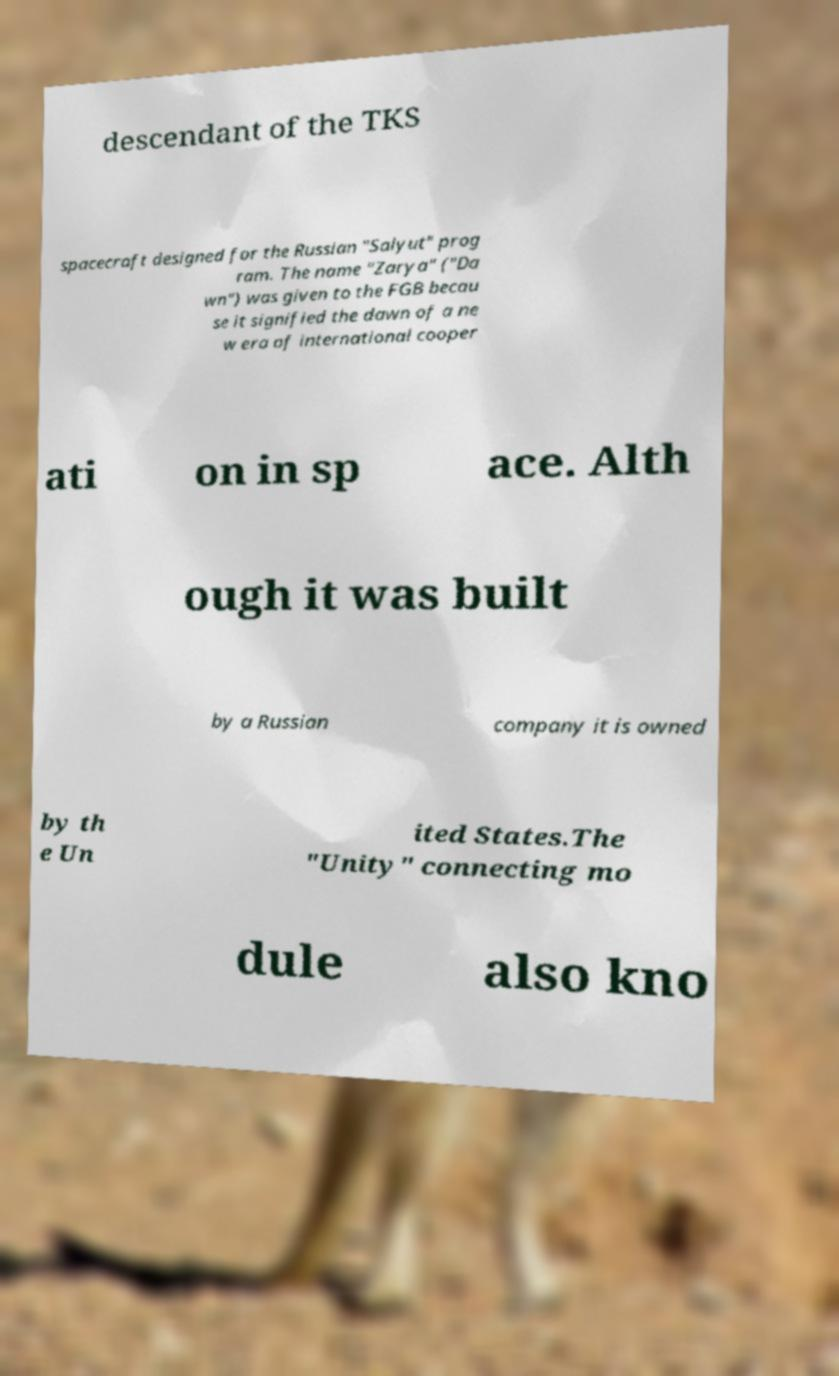For documentation purposes, I need the text within this image transcribed. Could you provide that? descendant of the TKS spacecraft designed for the Russian "Salyut" prog ram. The name "Zarya" ("Da wn") was given to the FGB becau se it signified the dawn of a ne w era of international cooper ati on in sp ace. Alth ough it was built by a Russian company it is owned by th e Un ited States.The "Unity" connecting mo dule also kno 